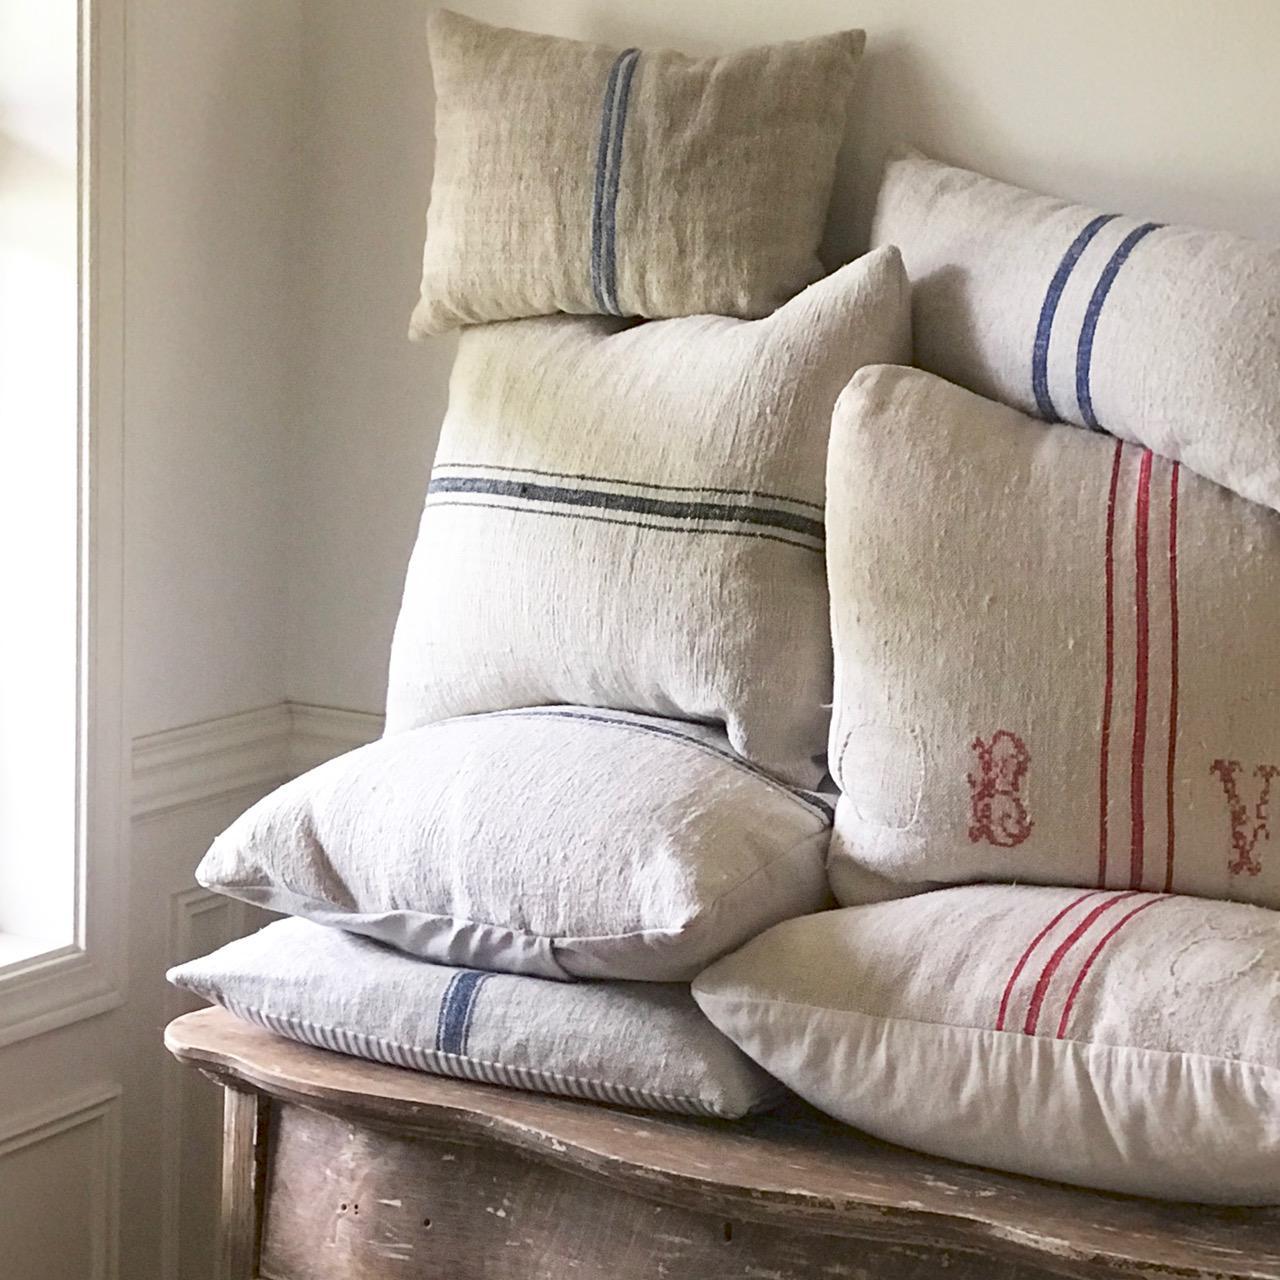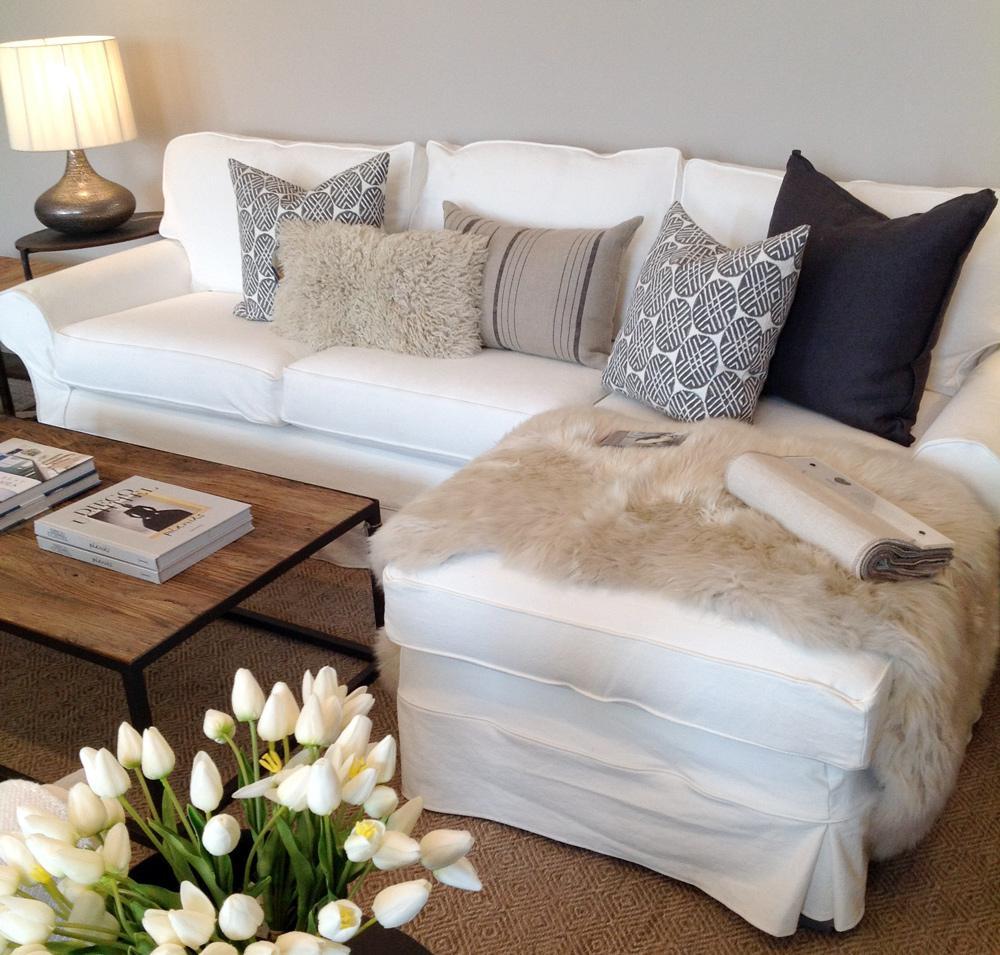The first image is the image on the left, the second image is the image on the right. Evaluate the accuracy of this statement regarding the images: "Each image features a bed made up with different pillows.". Is it true? Answer yes or no. No. 